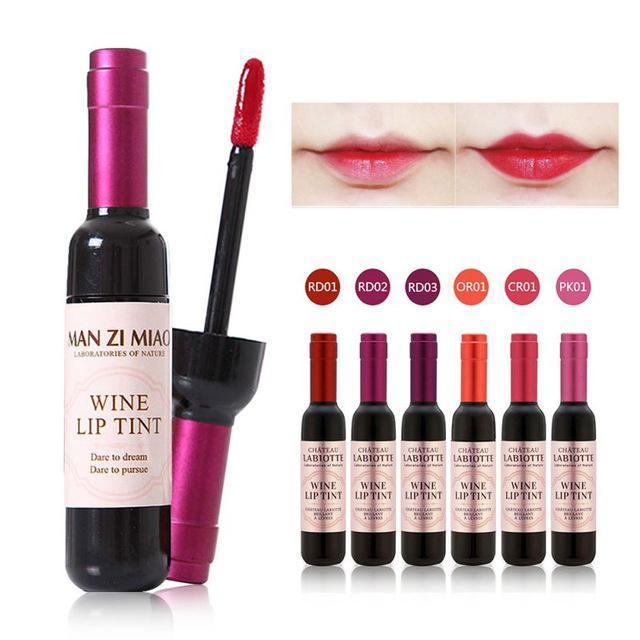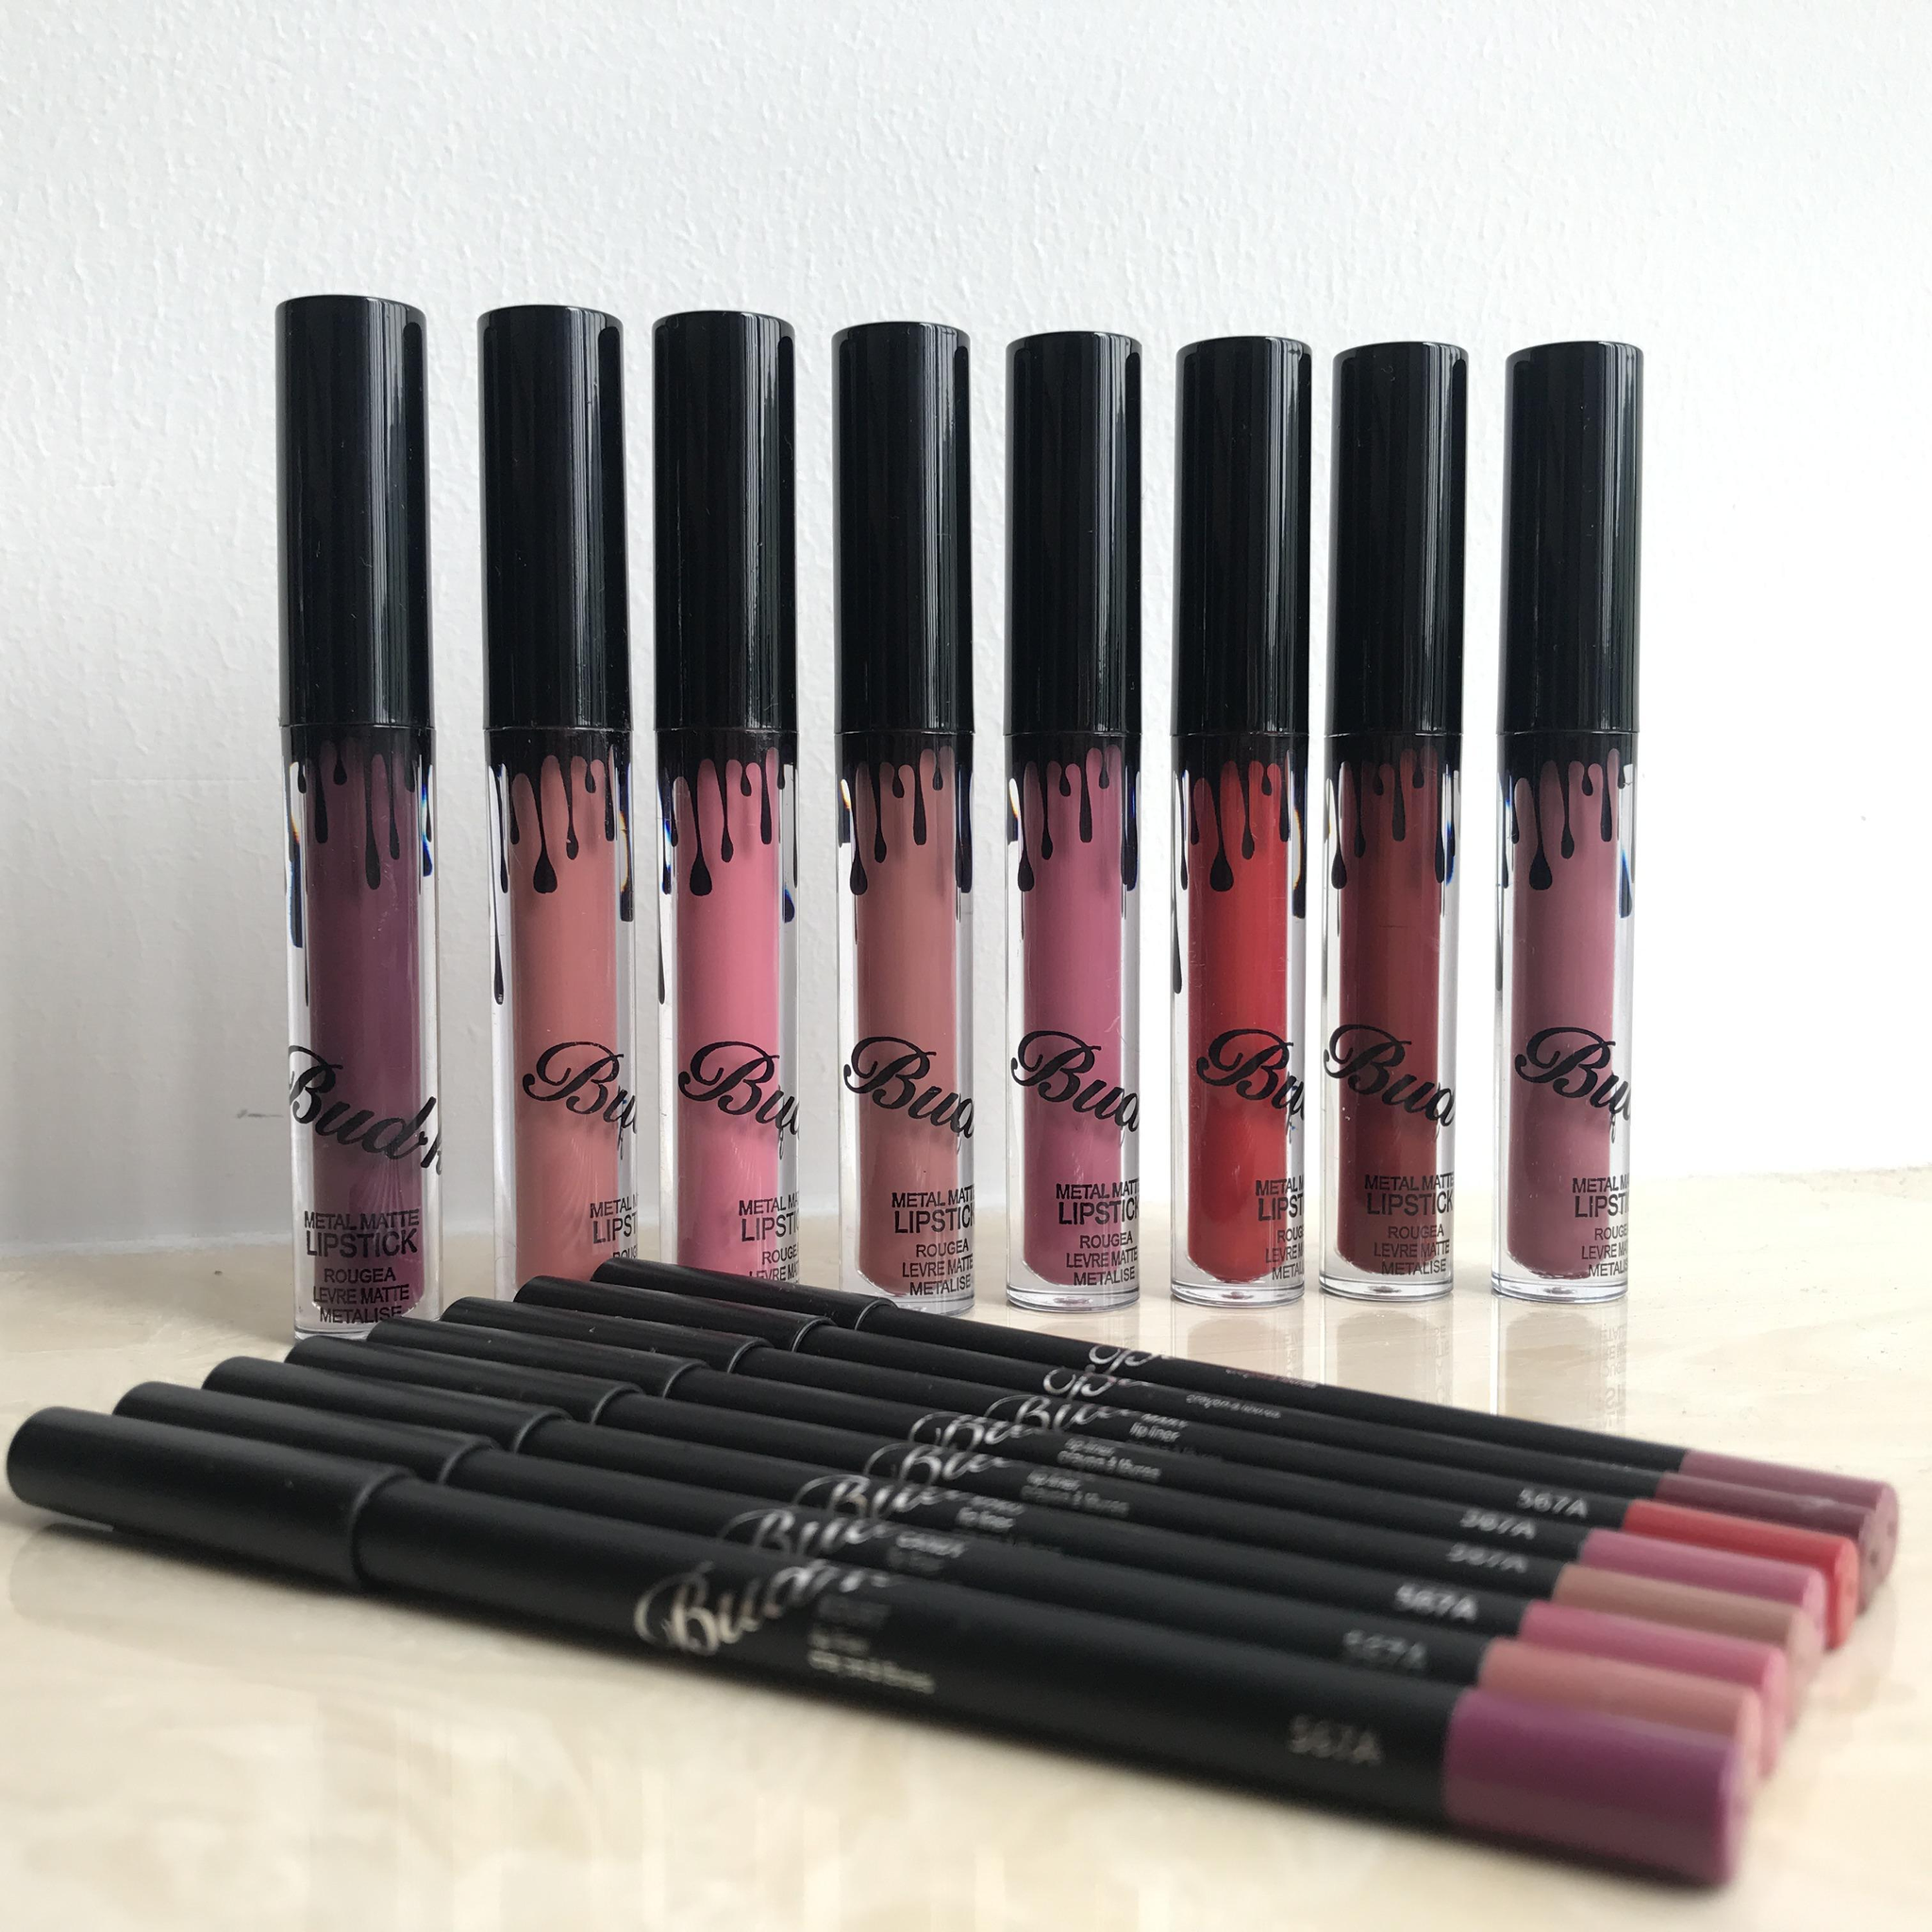The first image is the image on the left, the second image is the image on the right. Given the left and right images, does the statement "The right image includes an odd number of lipsticks standing up with their caps off." hold true? Answer yes or no. No. 